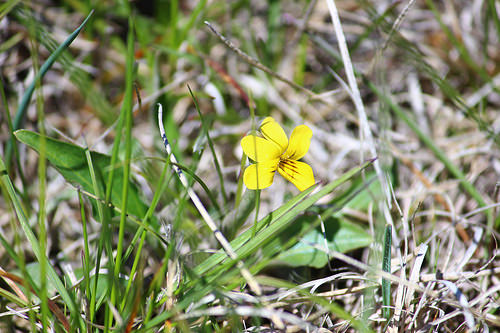<image>
Is the flower in the grass? Yes. The flower is contained within or inside the grass, showing a containment relationship. 